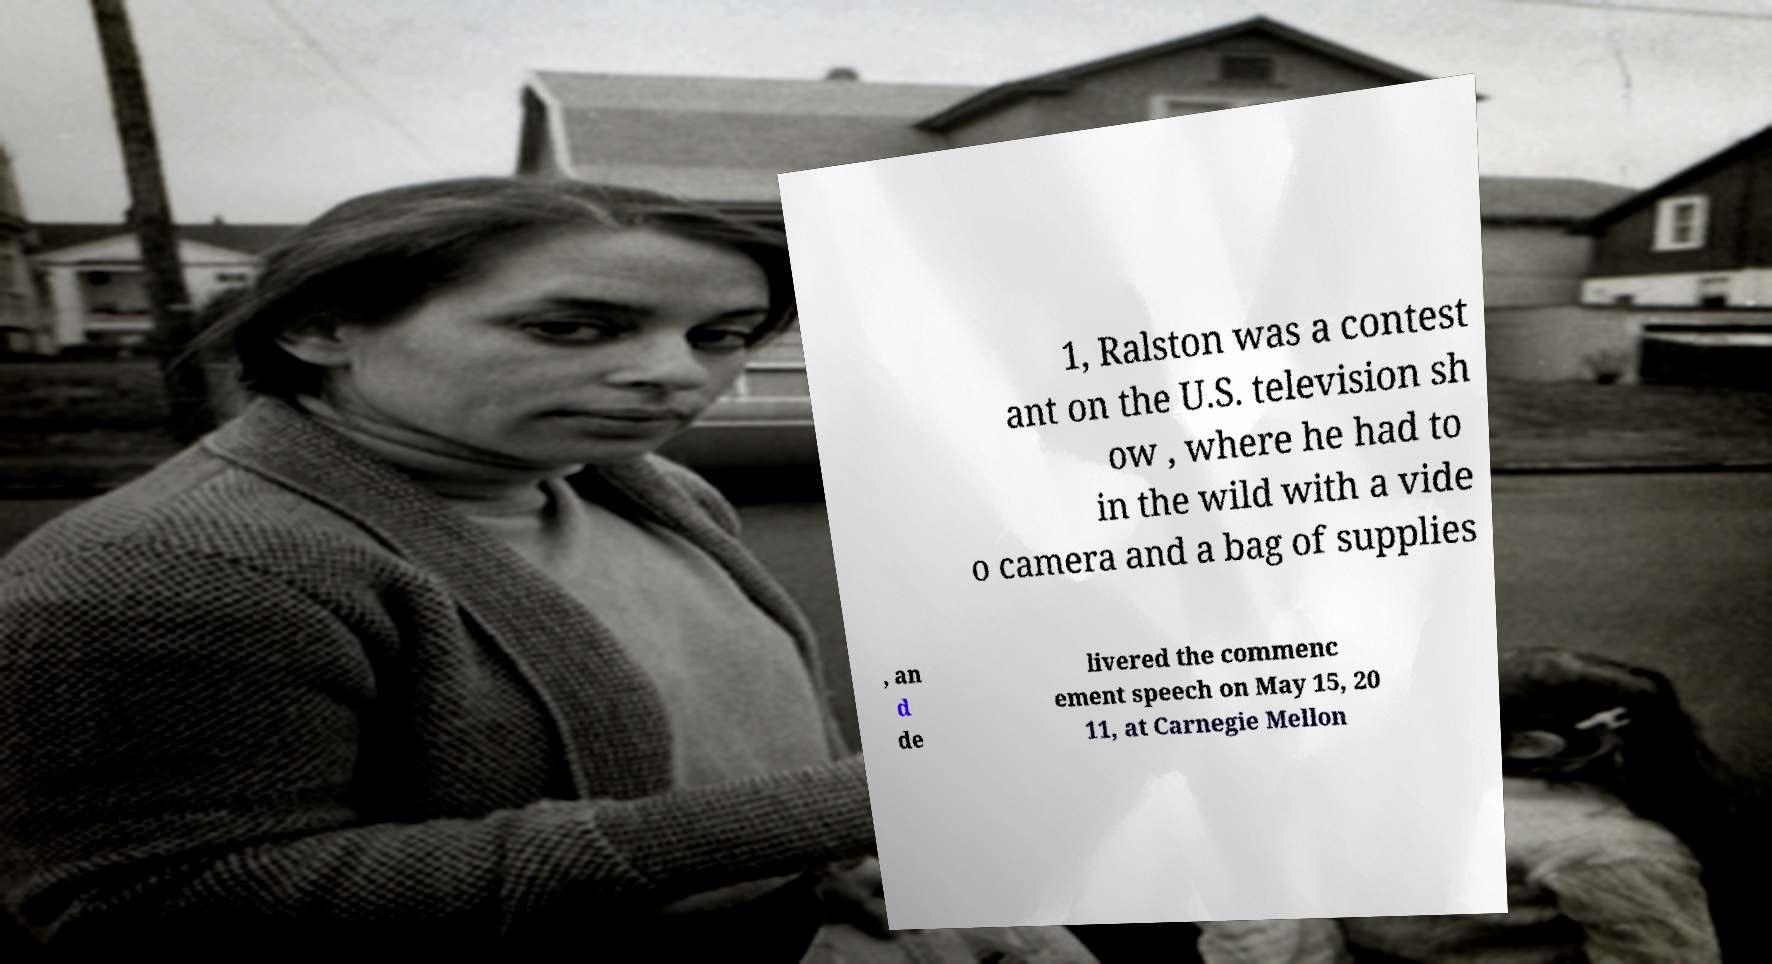There's text embedded in this image that I need extracted. Can you transcribe it verbatim? 1, Ralston was a contest ant on the U.S. television sh ow , where he had to in the wild with a vide o camera and a bag of supplies , an d de livered the commenc ement speech on May 15, 20 11, at Carnegie Mellon 